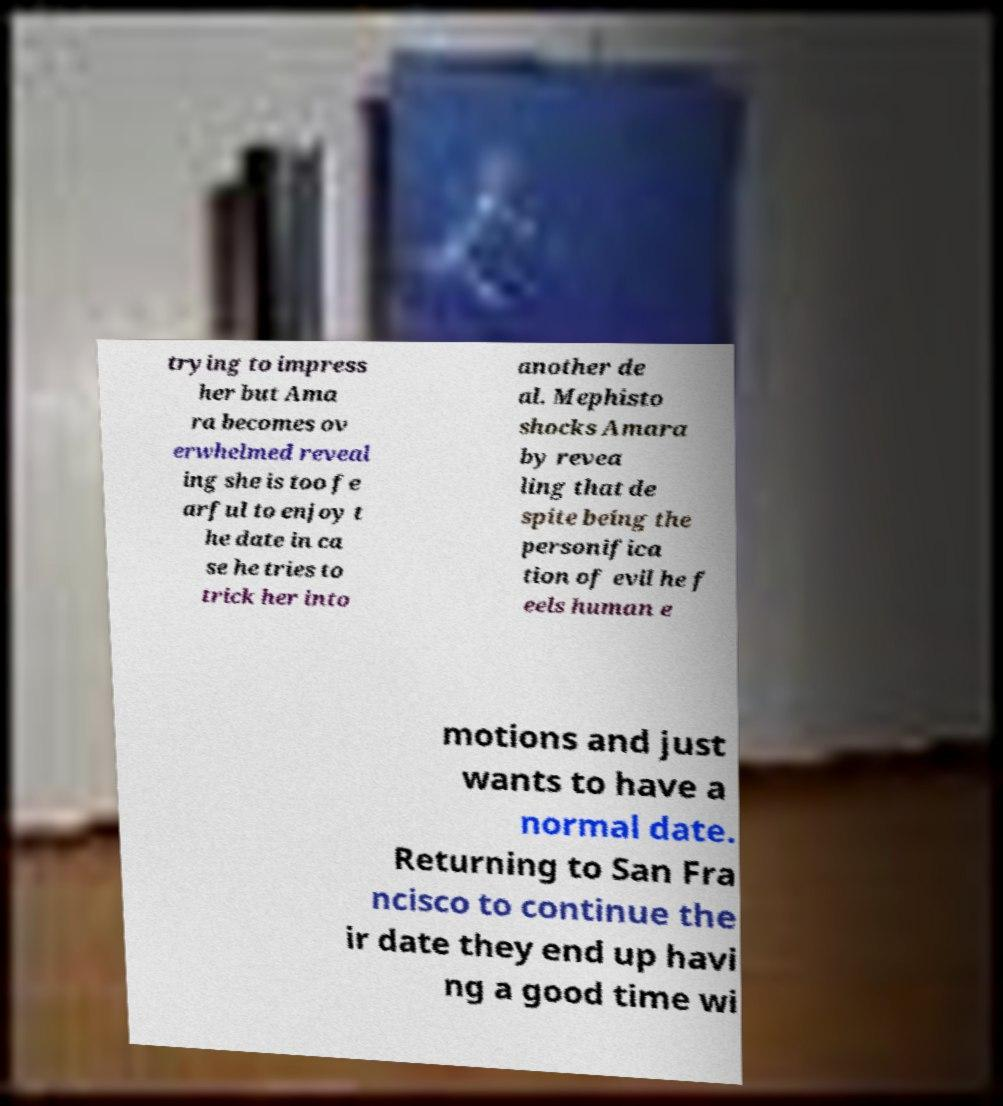There's text embedded in this image that I need extracted. Can you transcribe it verbatim? trying to impress her but Ama ra becomes ov erwhelmed reveal ing she is too fe arful to enjoy t he date in ca se he tries to trick her into another de al. Mephisto shocks Amara by revea ling that de spite being the personifica tion of evil he f eels human e motions and just wants to have a normal date. Returning to San Fra ncisco to continue the ir date they end up havi ng a good time wi 